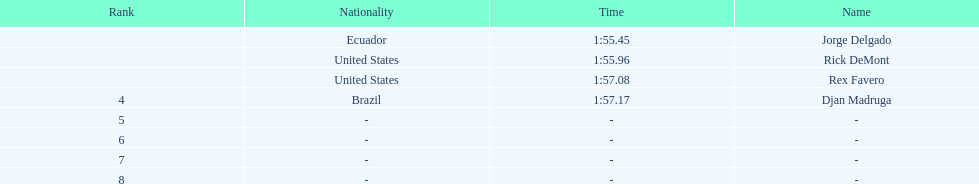What come after rex f. Djan Madruga. 